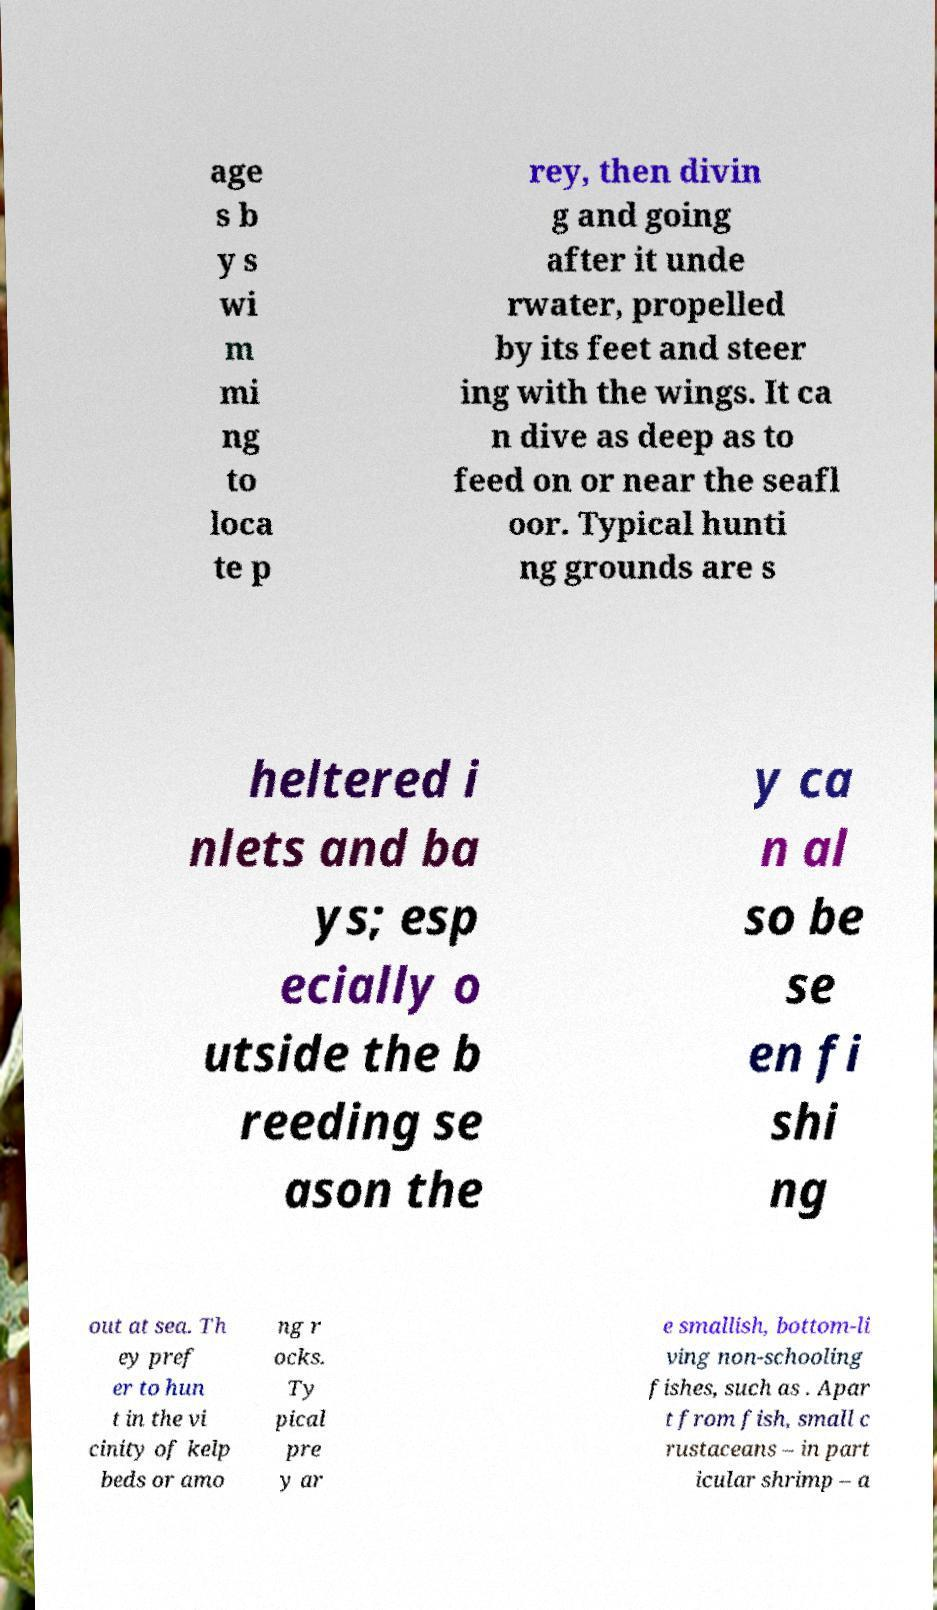I need the written content from this picture converted into text. Can you do that? age s b y s wi m mi ng to loca te p rey, then divin g and going after it unde rwater, propelled by its feet and steer ing with the wings. It ca n dive as deep as to feed on or near the seafl oor. Typical hunti ng grounds are s heltered i nlets and ba ys; esp ecially o utside the b reeding se ason the y ca n al so be se en fi shi ng out at sea. Th ey pref er to hun t in the vi cinity of kelp beds or amo ng r ocks. Ty pical pre y ar e smallish, bottom-li ving non-schooling fishes, such as . Apar t from fish, small c rustaceans – in part icular shrimp – a 